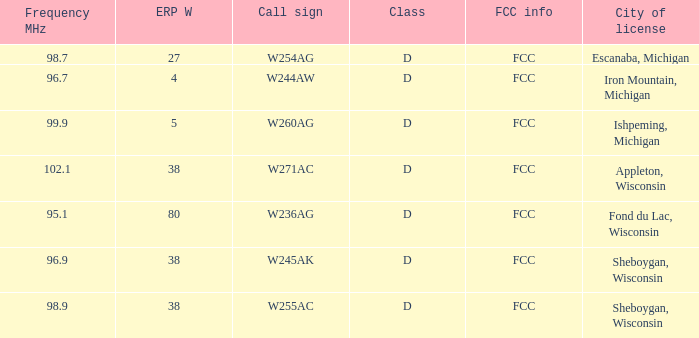What was the ERP W for 96.7 MHz? 4.0. Could you help me parse every detail presented in this table? {'header': ['Frequency MHz', 'ERP W', 'Call sign', 'Class', 'FCC info', 'City of license'], 'rows': [['98.7', '27', 'W254AG', 'D', 'FCC', 'Escanaba, Michigan'], ['96.7', '4', 'W244AW', 'D', 'FCC', 'Iron Mountain, Michigan'], ['99.9', '5', 'W260AG', 'D', 'FCC', 'Ishpeming, Michigan'], ['102.1', '38', 'W271AC', 'D', 'FCC', 'Appleton, Wisconsin'], ['95.1', '80', 'W236AG', 'D', 'FCC', 'Fond du Lac, Wisconsin'], ['96.9', '38', 'W245AK', 'D', 'FCC', 'Sheboygan, Wisconsin'], ['98.9', '38', 'W255AC', 'D', 'FCC', 'Sheboygan, Wisconsin']]} 